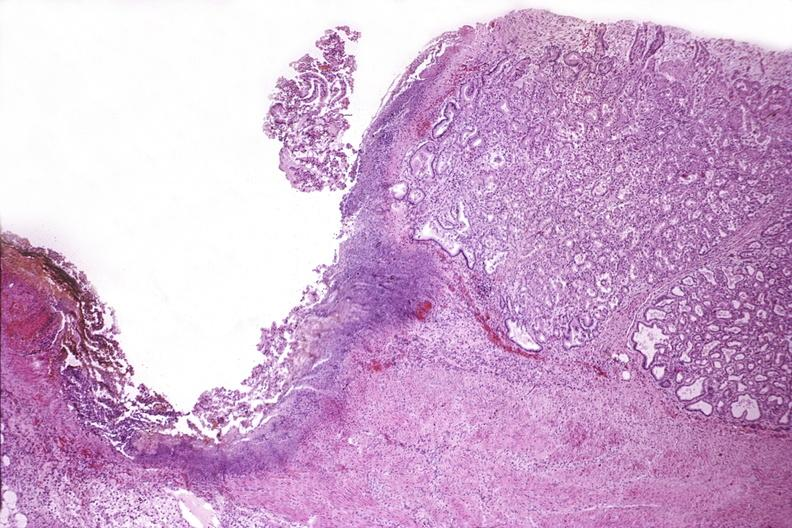s eosinophilic adenoma present?
Answer the question using a single word or phrase. No 